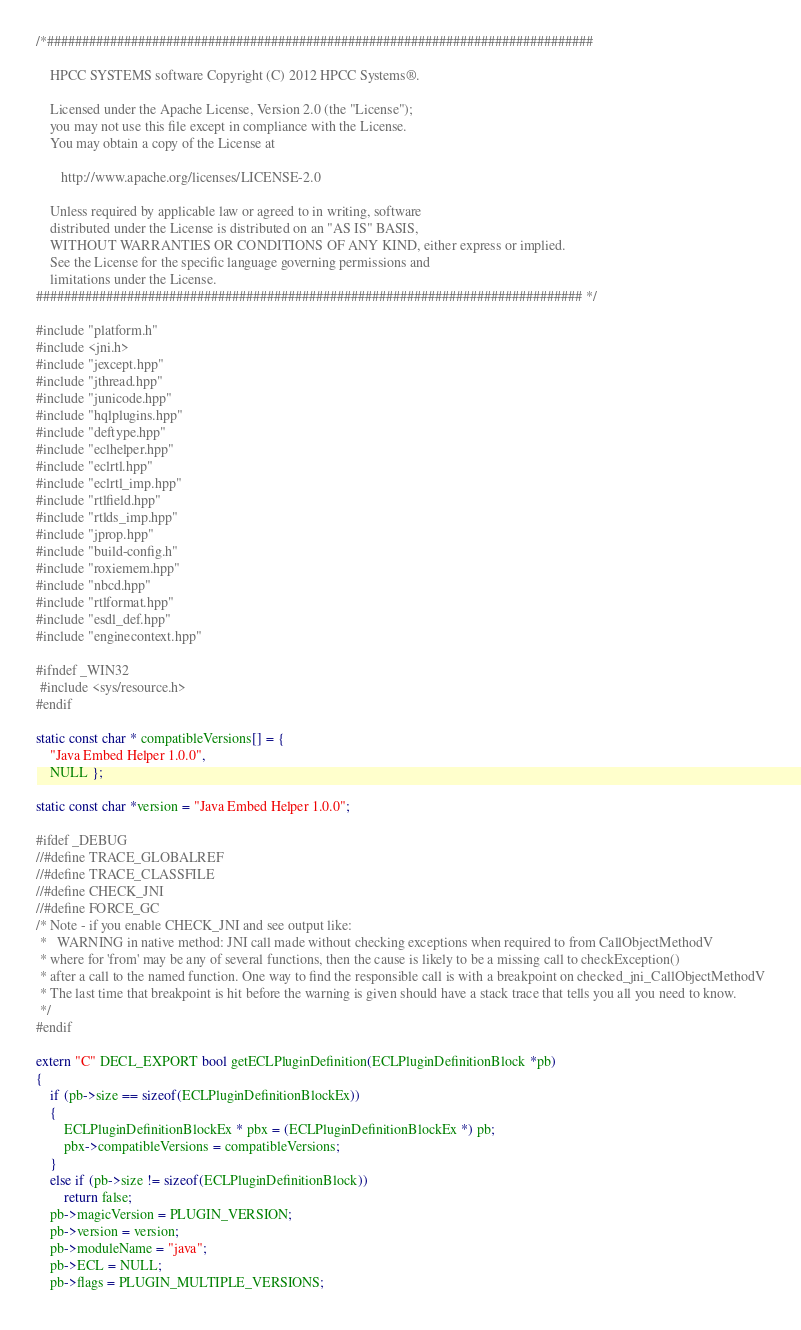<code> <loc_0><loc_0><loc_500><loc_500><_C++_>/*##############################################################################

    HPCC SYSTEMS software Copyright (C) 2012 HPCC Systems®.

    Licensed under the Apache License, Version 2.0 (the "License");
    you may not use this file except in compliance with the License.
    You may obtain a copy of the License at

       http://www.apache.org/licenses/LICENSE-2.0

    Unless required by applicable law or agreed to in writing, software
    distributed under the License is distributed on an "AS IS" BASIS,
    WITHOUT WARRANTIES OR CONDITIONS OF ANY KIND, either express or implied.
    See the License for the specific language governing permissions and
    limitations under the License.
############################################################################## */

#include "platform.h"
#include <jni.h>
#include "jexcept.hpp"
#include "jthread.hpp"
#include "junicode.hpp"
#include "hqlplugins.hpp"
#include "deftype.hpp"
#include "eclhelper.hpp"
#include "eclrtl.hpp"
#include "eclrtl_imp.hpp"
#include "rtlfield.hpp"
#include "rtlds_imp.hpp"
#include "jprop.hpp"
#include "build-config.h"
#include "roxiemem.hpp"
#include "nbcd.hpp"
#include "rtlformat.hpp"
#include "esdl_def.hpp"
#include "enginecontext.hpp"

#ifndef _WIN32
 #include <sys/resource.h>
#endif

static const char * compatibleVersions[] = {
    "Java Embed Helper 1.0.0",
    NULL };

static const char *version = "Java Embed Helper 1.0.0";

#ifdef _DEBUG
//#define TRACE_GLOBALREF
//#define TRACE_CLASSFILE
//#define CHECK_JNI
//#define FORCE_GC
/* Note - if you enable CHECK_JNI and see output like:
 *   WARNING in native method: JNI call made without checking exceptions when required to from CallObjectMethodV
 * where for 'from' may be any of several functions, then the cause is likely to be a missing call to checkException()
 * after a call to the named function. One way to find the responsible call is with a breakpoint on checked_jni_CallObjectMethodV
 * The last time that breakpoint is hit before the warning is given should have a stack trace that tells you all you need to know.
 */
#endif

extern "C" DECL_EXPORT bool getECLPluginDefinition(ECLPluginDefinitionBlock *pb)
{
    if (pb->size == sizeof(ECLPluginDefinitionBlockEx))
    {
        ECLPluginDefinitionBlockEx * pbx = (ECLPluginDefinitionBlockEx *) pb;
        pbx->compatibleVersions = compatibleVersions;
    }
    else if (pb->size != sizeof(ECLPluginDefinitionBlock))
        return false;
    pb->magicVersion = PLUGIN_VERSION;
    pb->version = version;
    pb->moduleName = "java";
    pb->ECL = NULL;
    pb->flags = PLUGIN_MULTIPLE_VERSIONS;</code> 